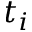Convert formula to latex. <formula><loc_0><loc_0><loc_500><loc_500>t _ { i }</formula> 